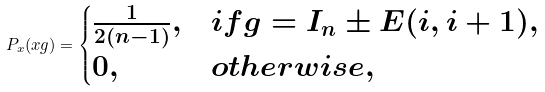<formula> <loc_0><loc_0><loc_500><loc_500>P _ { x } ( x g ) = \begin{cases} \frac { 1 } { 2 ( n - 1 ) } , & i f g = I _ { n } \pm E ( i , i + 1 ) , \\ 0 , & o t h e r w i s e , \end{cases}</formula> 